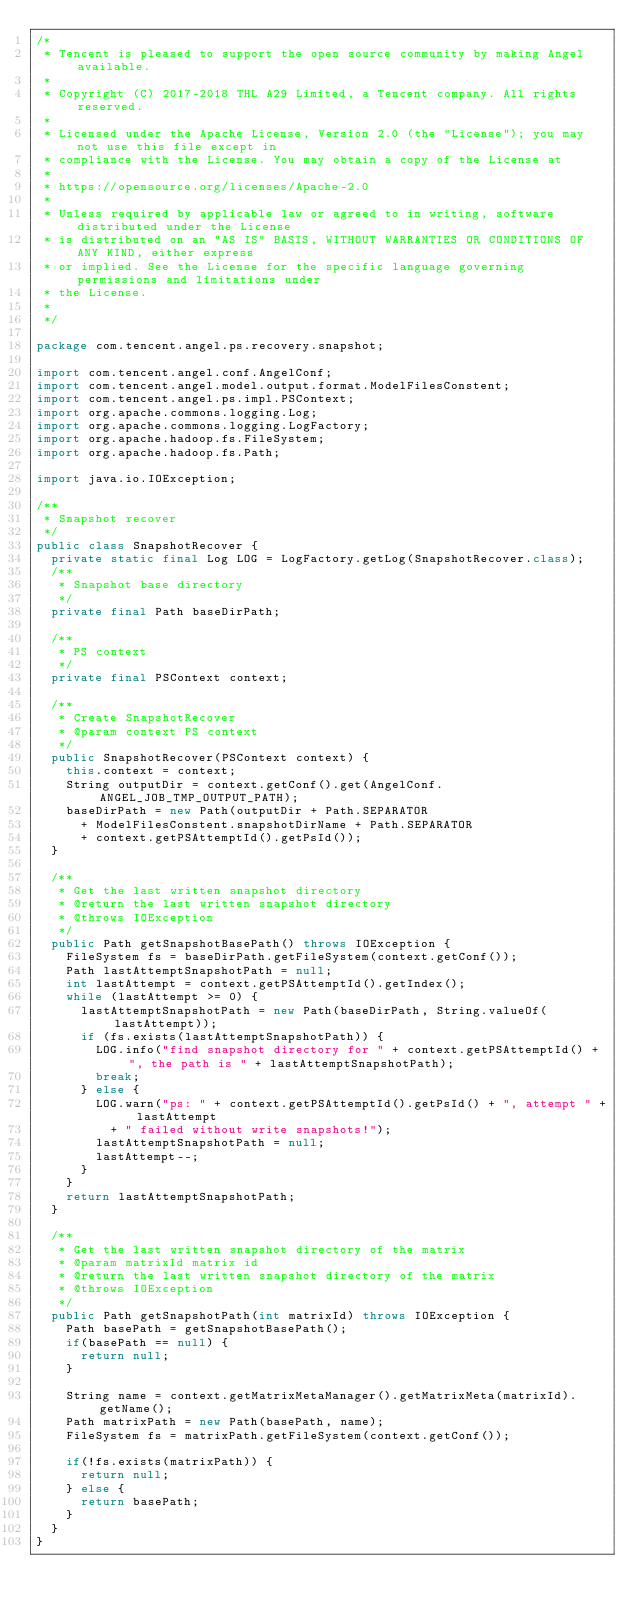<code> <loc_0><loc_0><loc_500><loc_500><_Java_>/*
 * Tencent is pleased to support the open source community by making Angel available.
 *
 * Copyright (C) 2017-2018 THL A29 Limited, a Tencent company. All rights reserved.
 *
 * Licensed under the Apache License, Version 2.0 (the "License"); you may not use this file except in 
 * compliance with the License. You may obtain a copy of the License at
 *
 * https://opensource.org/licenses/Apache-2.0
 *
 * Unless required by applicable law or agreed to in writing, software distributed under the License
 * is distributed on an "AS IS" BASIS, WITHOUT WARRANTIES OR CONDITIONS OF ANY KIND, either express
 * or implied. See the License for the specific language governing permissions and limitations under
 * the License.
 *
 */

package com.tencent.angel.ps.recovery.snapshot;

import com.tencent.angel.conf.AngelConf;
import com.tencent.angel.model.output.format.ModelFilesConstent;
import com.tencent.angel.ps.impl.PSContext;
import org.apache.commons.logging.Log;
import org.apache.commons.logging.LogFactory;
import org.apache.hadoop.fs.FileSystem;
import org.apache.hadoop.fs.Path;

import java.io.IOException;

/**
 * Snapshot recover
 */
public class SnapshotRecover {
  private static final Log LOG = LogFactory.getLog(SnapshotRecover.class);
  /**
   * Snapshot base directory
   */
  private final Path baseDirPath;

  /**
   * PS context
   */
  private final PSContext context;

  /**
   * Create SnapshotRecover
   * @param context PS context
   */
  public SnapshotRecover(PSContext context) {
    this.context = context;
    String outputDir = context.getConf().get(AngelConf.ANGEL_JOB_TMP_OUTPUT_PATH);
    baseDirPath = new Path(outputDir + Path.SEPARATOR
      + ModelFilesConstent.snapshotDirName + Path.SEPARATOR
      + context.getPSAttemptId().getPsId());
  }

  /**
   * Get the last written snapshot directory
   * @return the last written snapshot directory
   * @throws IOException
   */
  public Path getSnapshotBasePath() throws IOException {
    FileSystem fs = baseDirPath.getFileSystem(context.getConf());
    Path lastAttemptSnapshotPath = null;
    int lastAttempt = context.getPSAttemptId().getIndex();
    while (lastAttempt >= 0) {
      lastAttemptSnapshotPath = new Path(baseDirPath, String.valueOf(lastAttempt));
      if (fs.exists(lastAttemptSnapshotPath)) {
        LOG.info("find snapshot directory for " + context.getPSAttemptId() + ", the path is " + lastAttemptSnapshotPath);
        break;
      } else {
        LOG.warn("ps: " + context.getPSAttemptId().getPsId() + ", attempt " + lastAttempt
          + " failed without write snapshots!");
        lastAttemptSnapshotPath = null;
        lastAttempt--;
      }
    }
    return lastAttemptSnapshotPath;
  }

  /**
   * Get the last written snapshot directory of the matrix
   * @param matrixId matrix id
   * @return the last written snapshot directory of the matrix
   * @throws IOException
   */
  public Path getSnapshotPath(int matrixId) throws IOException {
    Path basePath = getSnapshotBasePath();
    if(basePath == null) {
      return null;
    }

    String name = context.getMatrixMetaManager().getMatrixMeta(matrixId).getName();
    Path matrixPath = new Path(basePath, name);
    FileSystem fs = matrixPath.getFileSystem(context.getConf());

    if(!fs.exists(matrixPath)) {
      return null;
    } else {
      return basePath;
    }
  }
}
</code> 